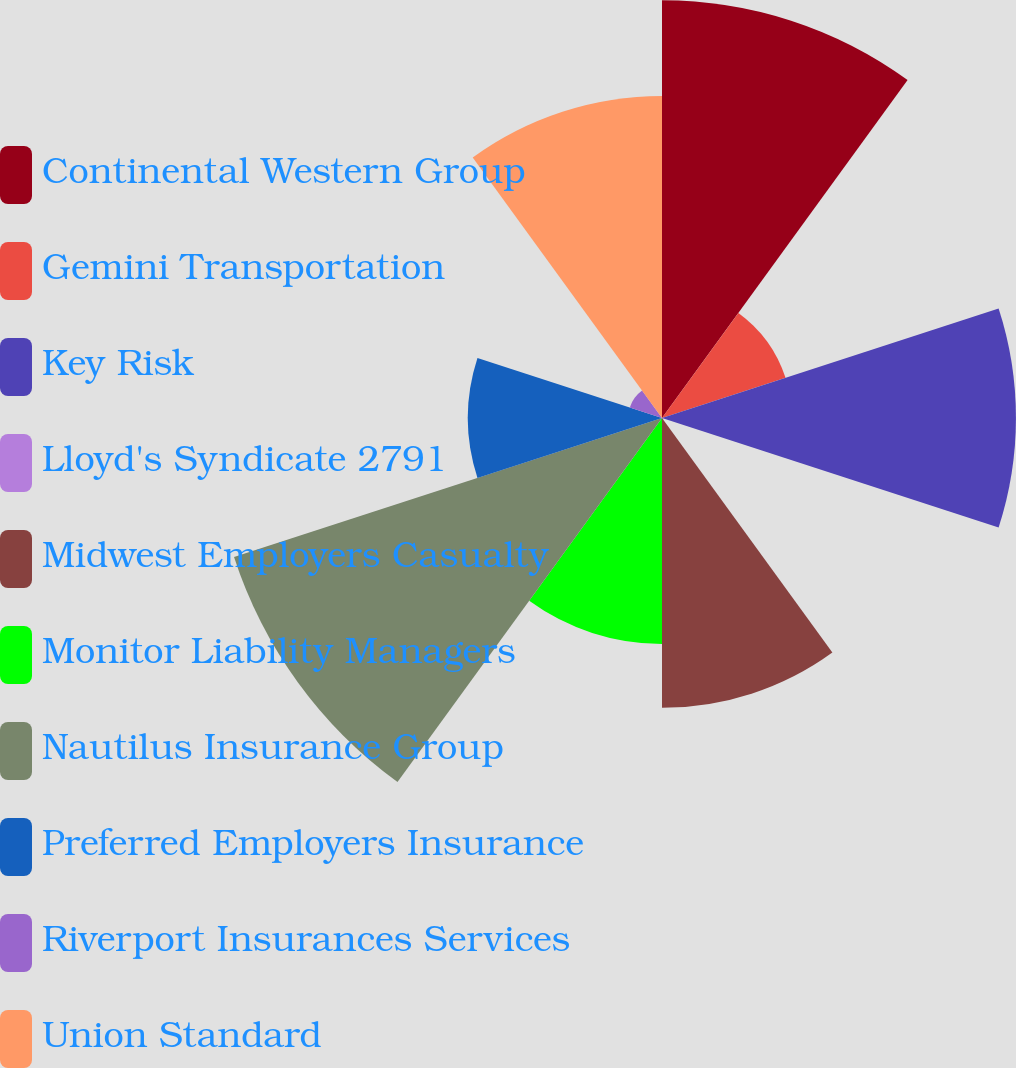Convert chart. <chart><loc_0><loc_0><loc_500><loc_500><pie_chart><fcel>Continental Western Group<fcel>Gemini Transportation<fcel>Key Risk<fcel>Lloyd's Syndicate 2791<fcel>Midwest Employers Casualty<fcel>Monitor Liability Managers<fcel>Nautilus Insurance Group<fcel>Preferred Employers Insurance<fcel>Riverport Insurances Services<fcel>Union Standard<nl><fcel>17.27%<fcel>5.37%<fcel>14.63%<fcel>0.08%<fcel>11.98%<fcel>9.34%<fcel>18.6%<fcel>8.02%<fcel>1.4%<fcel>13.31%<nl></chart> 